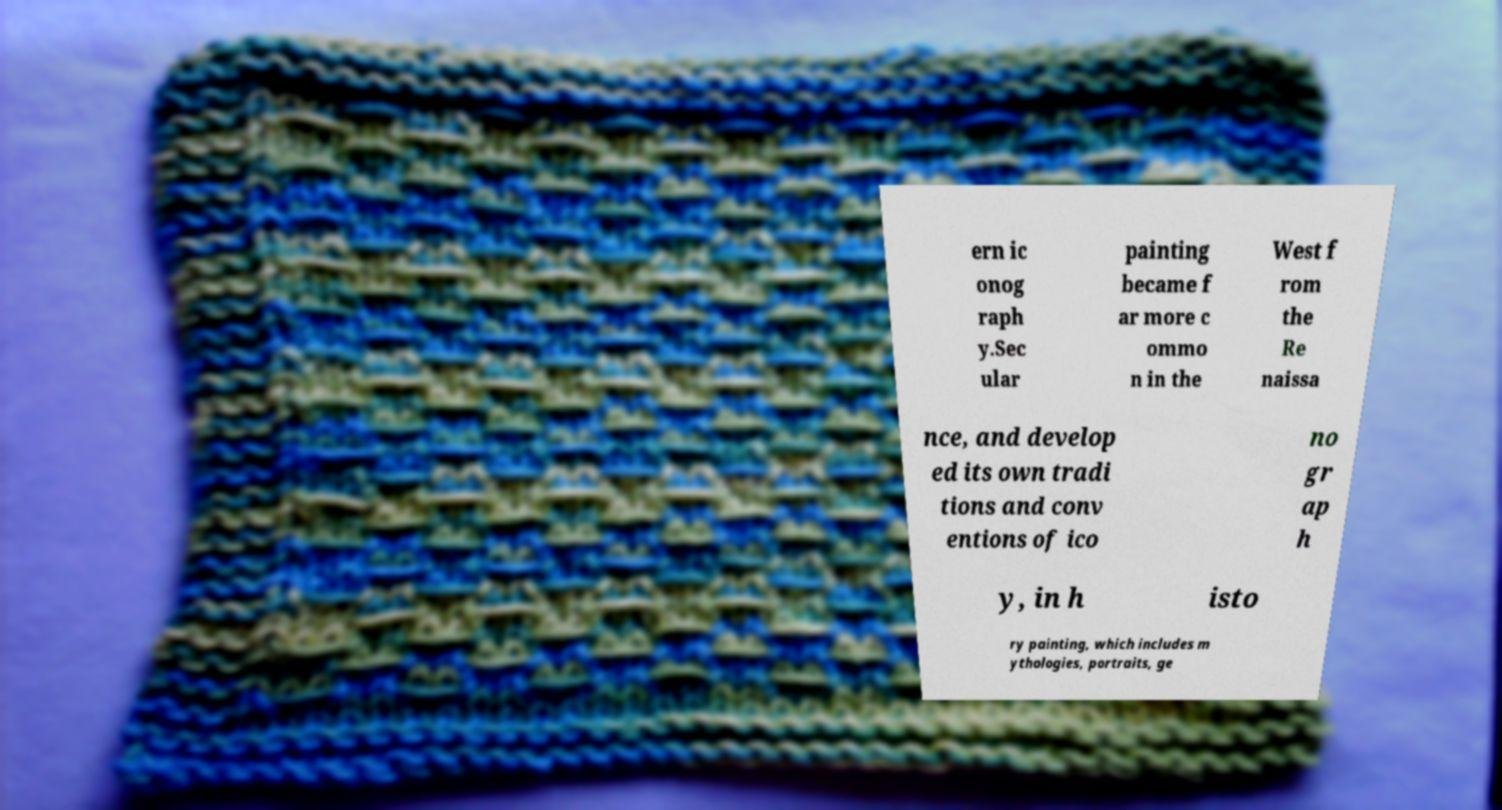Please identify and transcribe the text found in this image. ern ic onog raph y.Sec ular painting became f ar more c ommo n in the West f rom the Re naissa nce, and develop ed its own tradi tions and conv entions of ico no gr ap h y, in h isto ry painting, which includes m ythologies, portraits, ge 